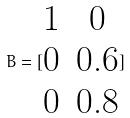Convert formula to latex. <formula><loc_0><loc_0><loc_500><loc_500>B = [ \begin{matrix} 1 & 0 \\ 0 & 0 . 6 \\ 0 & 0 . 8 \end{matrix} ]</formula> 